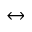Convert formula to latex. <formula><loc_0><loc_0><loc_500><loc_500>\leftrightarrow</formula> 